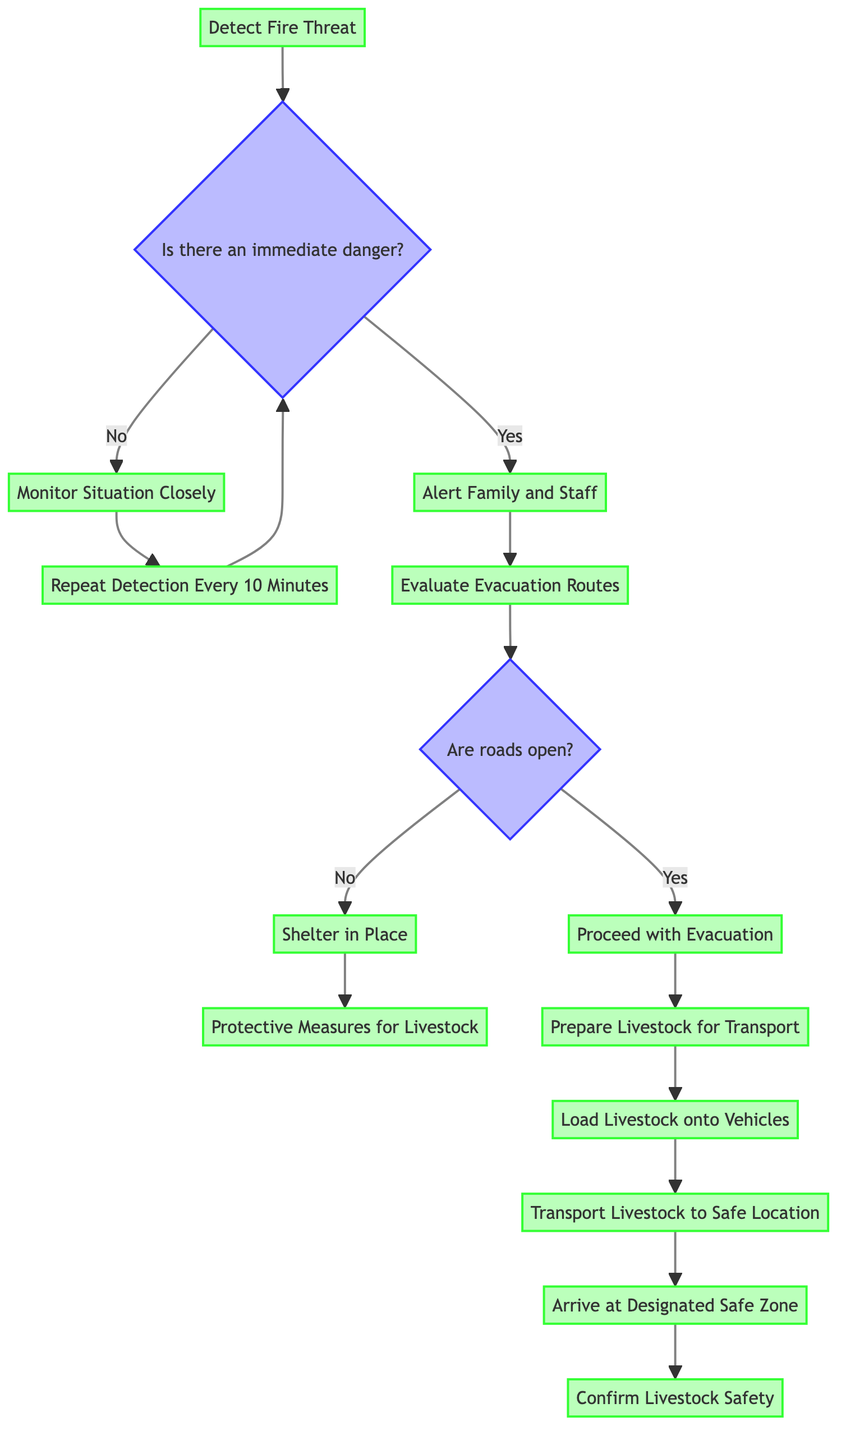What is the initial action in the flowchart? The flowchart starts with the action of detecting the fire threat. This is the first node in the diagram, which indicates that the process begins with this detection task.
Answer: Detect Fire Threat How many operations are listed in the diagram? Counting all the individual operation nodes in the flowchart, there are ten operations that describe various steps taken in response to a fire threat.
Answer: Ten What happens if there is no immediate danger? If there is no immediate danger, the next step in the flowchart is to monitor the situation closely. This is the response outlined for the false outcome of the immediate danger check.
Answer: Monitor Situation Closely What action is taken after proceeding with evacuation? After proceeding with evacuation, the next action outlined is to prepare livestock for transport. This follows directly after the decision to evacuate.
Answer: Prepare Livestock for Transport What are the protective measures for livestock when sheltering in place? When sheltering in place, the protective measures for livestock include moving livestock to a cleared area with minimal vegetation, providing water and feed, and monitoring fire updates. These measures are outlined as necessary actions under this node.
Answer: Move livestock to cleared area with minimal vegetation; Provide water and feed; Monitor fire updates What condition must be assessed after alerting family and staff? Following the alerting of family and staff, the next condition that must be assessed is whether the roads are open, as this determines the next steps for either evacuation or sheltering in place.
Answer: Are roads open? Describe the final outcome of the evacuation plan. The final outcome of the evacuation plan detailed in this flowchart is the confirmation of livestock safety. This is the end point of the flowchart, representing the goal of the entire process.
Answer: Confirm Livestock Safety What is the frequency for repeating the detection of fire threat? The plan specifies that the detection of the fire threat should be repeated every 10 minutes if there is no immediate danger. This indicates a proactive approach to monitor changes in fire threat levels.
Answer: Every 10 Minutes What must be gathered before preparing livestock for transport? Before preparing livestock for transport, it is necessary to gather livestock at the loading area and ensure all necessary documentation is ready, including health records and ownership identification. This detail outlines the preparations needed for transport.
Answer: Gather livestock at the loading area; Ensure all necessary documentation is ready (e.g., health records, ownership identification) 